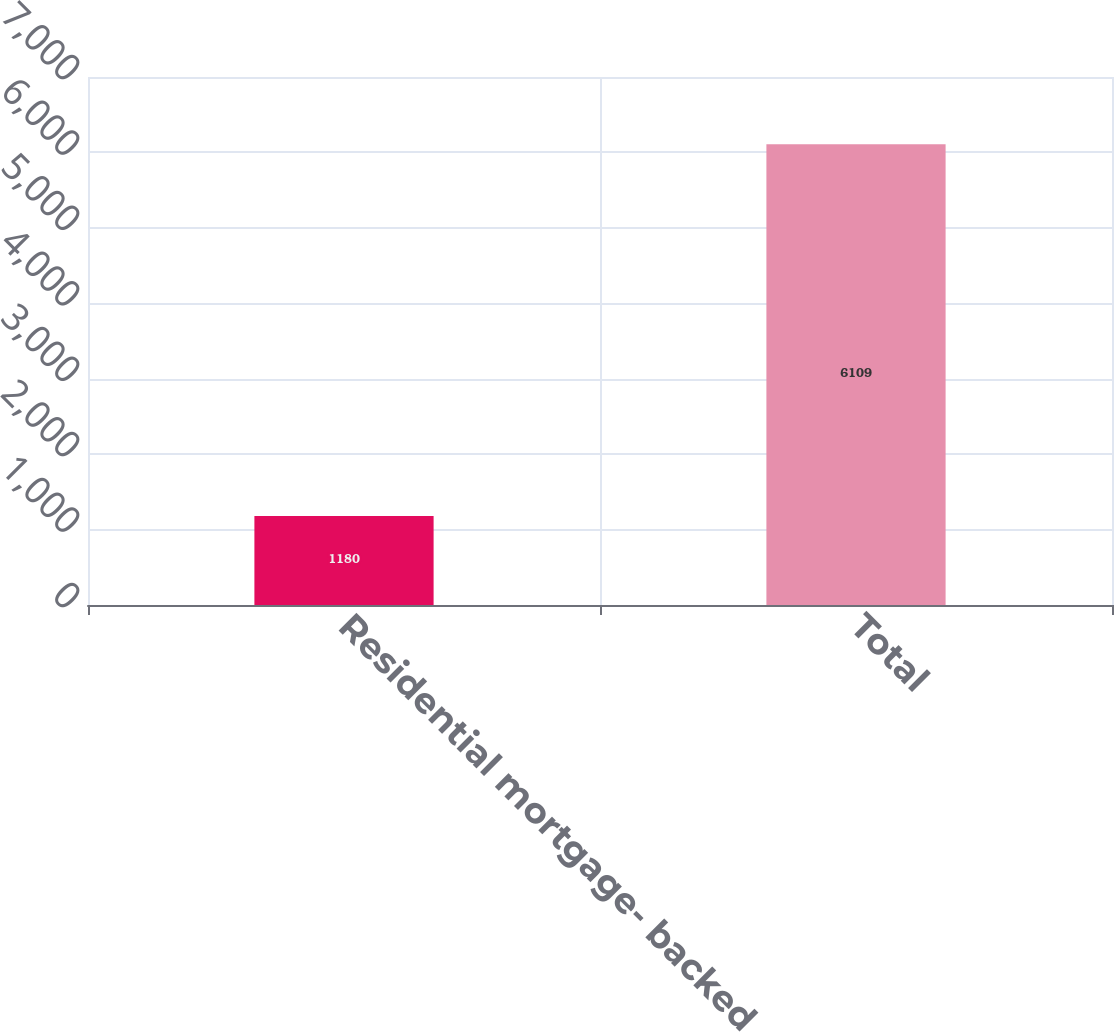<chart> <loc_0><loc_0><loc_500><loc_500><bar_chart><fcel>Residential mortgage- backed<fcel>Total<nl><fcel>1180<fcel>6109<nl></chart> 